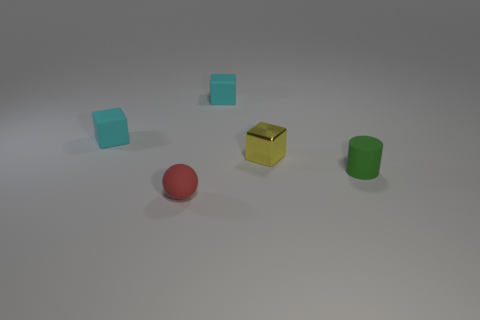Subtract all small rubber cubes. How many cubes are left? 1 Add 3 tiny cyan matte objects. How many objects exist? 8 Subtract all yellow blocks. How many blocks are left? 2 Subtract all green cylinders. How many cyan cubes are left? 2 Subtract all cylinders. How many objects are left? 4 Add 5 small cyan matte cubes. How many small cyan matte cubes are left? 7 Add 5 small cyan objects. How many small cyan objects exist? 7 Subtract 0 purple blocks. How many objects are left? 5 Subtract 1 spheres. How many spheres are left? 0 Subtract all purple cylinders. Subtract all purple blocks. How many cylinders are left? 1 